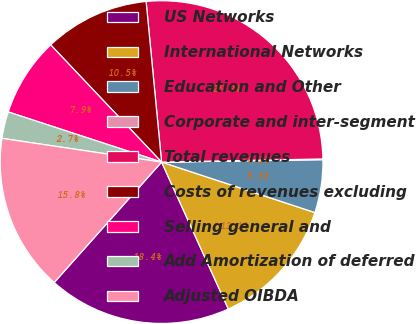<chart> <loc_0><loc_0><loc_500><loc_500><pie_chart><fcel>US Networks<fcel>International Networks<fcel>Education and Other<fcel>Corporate and inter-segment<fcel>Total revenues<fcel>Costs of revenues excluding<fcel>Selling general and<fcel>Add Amortization of deferred<fcel>Adjusted OIBDA<nl><fcel>18.38%<fcel>13.15%<fcel>5.3%<fcel>0.07%<fcel>26.22%<fcel>10.53%<fcel>7.91%<fcel>2.68%<fcel>15.76%<nl></chart> 